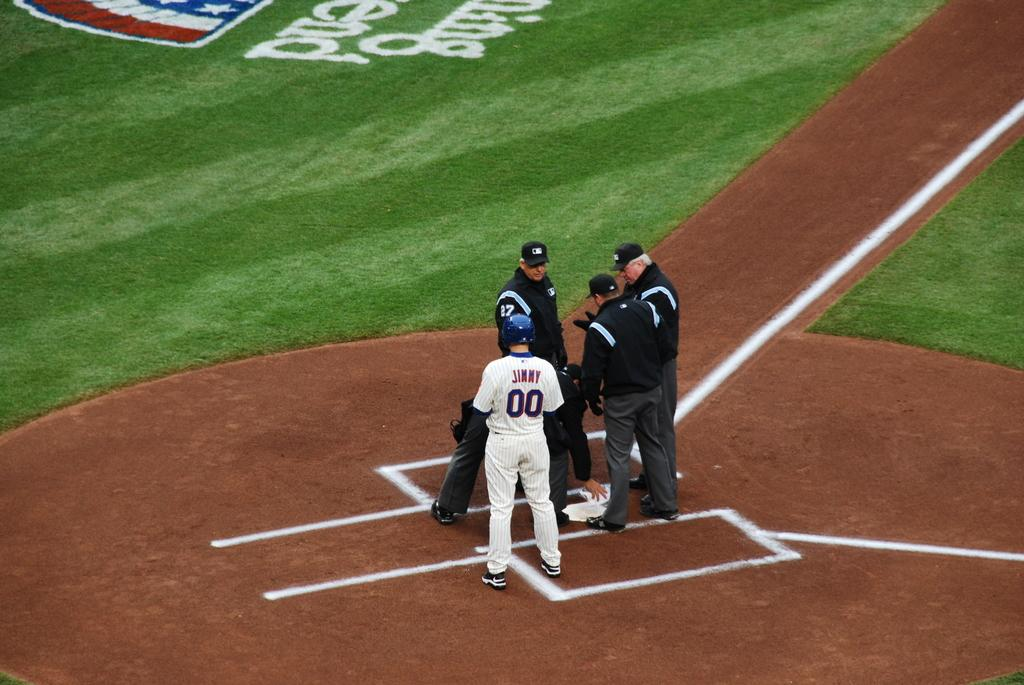<image>
Provide a brief description of the given image. A baseball player named Jimmy wears number 00. 